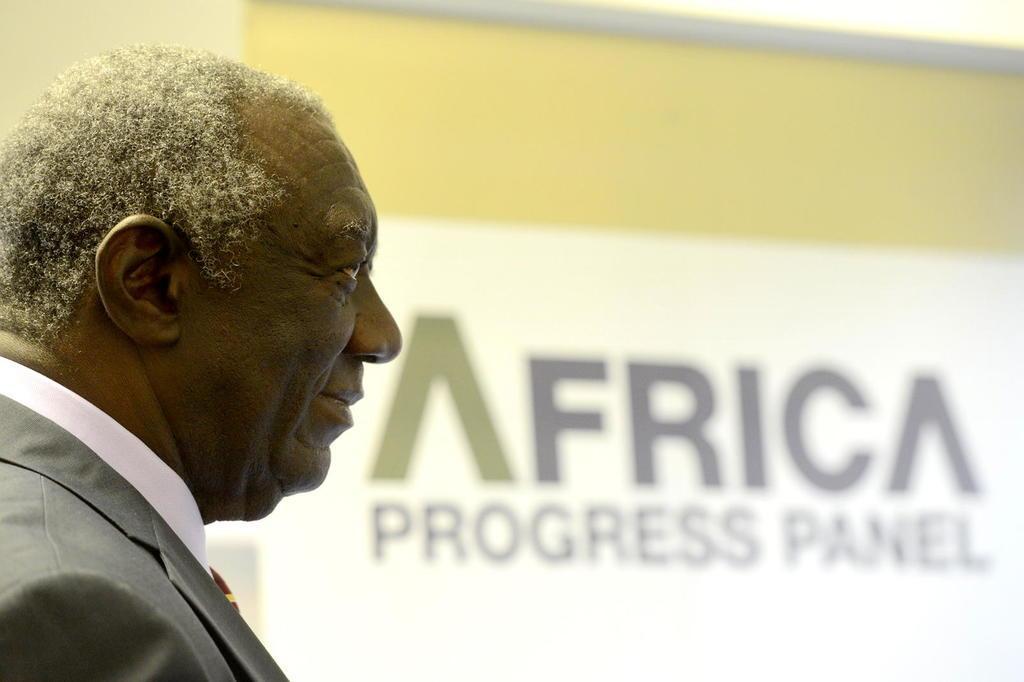Could you give a brief overview of what you see in this image? The man on the left side wearing a white shirt and grey blazer is smiling. In the background, we see a white banner or a projector screen with text displayed on it. Behind that, we see a wall. 